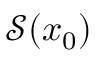Convert formula to latex. <formula><loc_0><loc_0><loc_500><loc_500>{ \mathcal { S } } ( x _ { 0 } )</formula> 